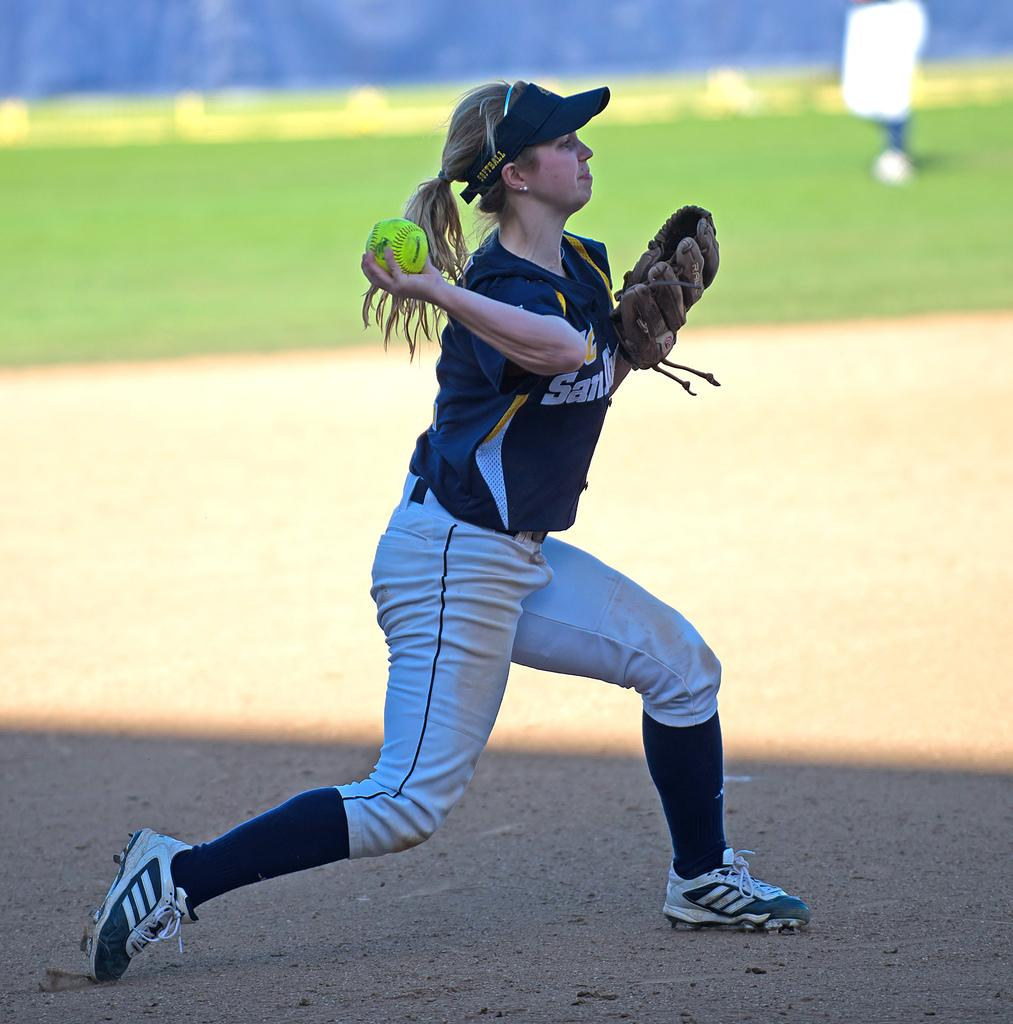<image>
Offer a succinct explanation of the picture presented. Girl wearing a visor that says SOFTBALL pitching a baseball. 